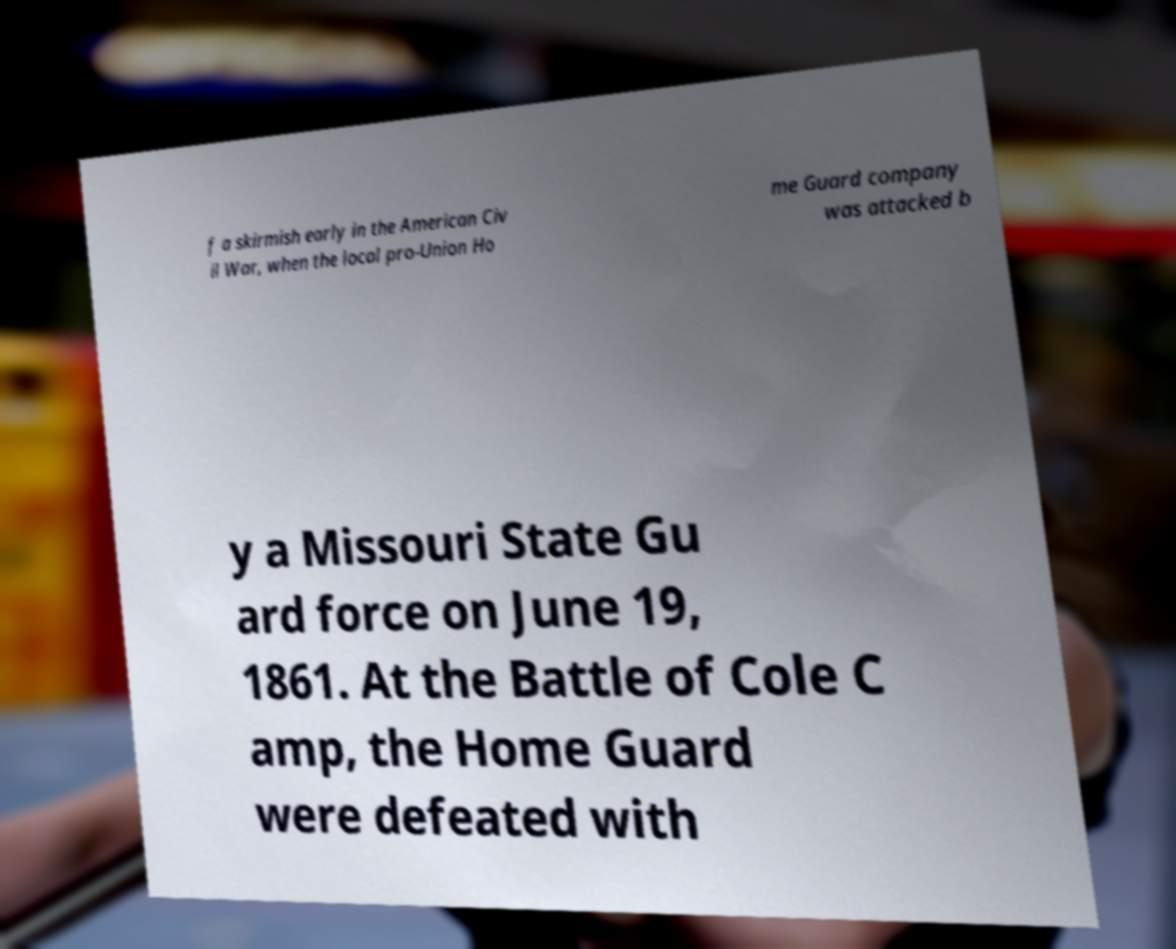What messages or text are displayed in this image? I need them in a readable, typed format. f a skirmish early in the American Civ il War, when the local pro-Union Ho me Guard company was attacked b y a Missouri State Gu ard force on June 19, 1861. At the Battle of Cole C amp, the Home Guard were defeated with 